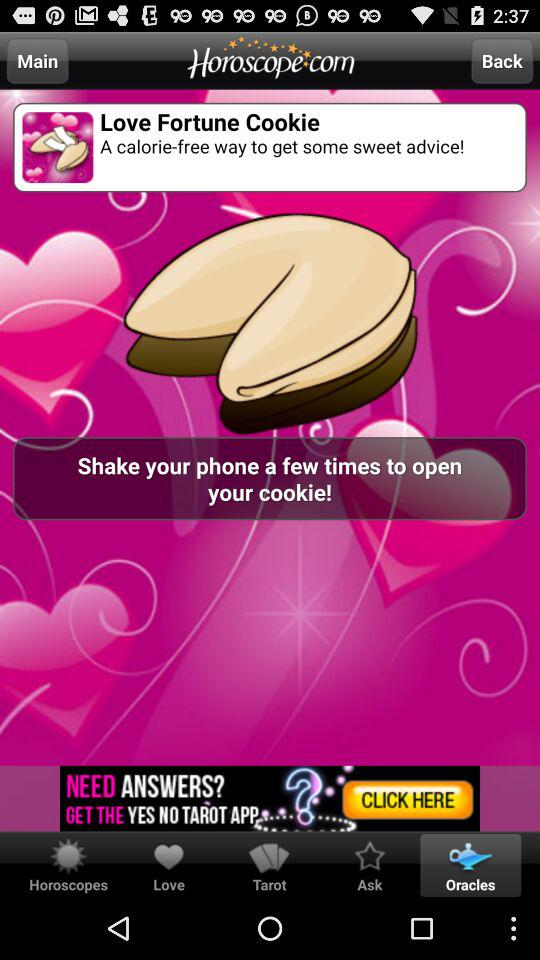What is the application name? The application name is "Horoscope com". 